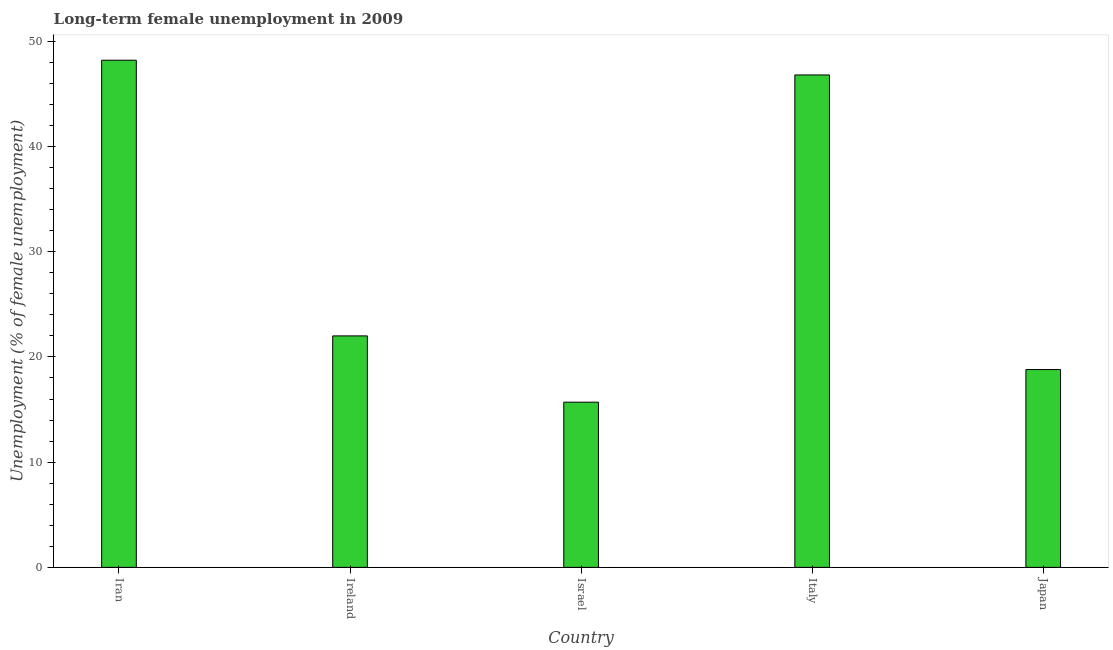Does the graph contain grids?
Offer a terse response. No. What is the title of the graph?
Provide a short and direct response. Long-term female unemployment in 2009. What is the label or title of the Y-axis?
Your answer should be compact. Unemployment (% of female unemployment). What is the long-term female unemployment in Ireland?
Give a very brief answer. 22. Across all countries, what is the maximum long-term female unemployment?
Your answer should be very brief. 48.2. Across all countries, what is the minimum long-term female unemployment?
Offer a terse response. 15.7. In which country was the long-term female unemployment maximum?
Give a very brief answer. Iran. In which country was the long-term female unemployment minimum?
Ensure brevity in your answer.  Israel. What is the sum of the long-term female unemployment?
Provide a succinct answer. 151.5. What is the difference between the long-term female unemployment in Ireland and Israel?
Make the answer very short. 6.3. What is the average long-term female unemployment per country?
Your response must be concise. 30.3. What is the median long-term female unemployment?
Give a very brief answer. 22. What is the ratio of the long-term female unemployment in Ireland to that in Japan?
Provide a short and direct response. 1.17. Is the long-term female unemployment in Iran less than that in Israel?
Keep it short and to the point. No. What is the difference between the highest and the second highest long-term female unemployment?
Give a very brief answer. 1.4. What is the difference between the highest and the lowest long-term female unemployment?
Keep it short and to the point. 32.5. What is the difference between two consecutive major ticks on the Y-axis?
Provide a short and direct response. 10. What is the Unemployment (% of female unemployment) of Iran?
Your response must be concise. 48.2. What is the Unemployment (% of female unemployment) of Ireland?
Offer a very short reply. 22. What is the Unemployment (% of female unemployment) of Israel?
Offer a terse response. 15.7. What is the Unemployment (% of female unemployment) of Italy?
Give a very brief answer. 46.8. What is the Unemployment (% of female unemployment) of Japan?
Ensure brevity in your answer.  18.8. What is the difference between the Unemployment (% of female unemployment) in Iran and Ireland?
Offer a terse response. 26.2. What is the difference between the Unemployment (% of female unemployment) in Iran and Israel?
Offer a very short reply. 32.5. What is the difference between the Unemployment (% of female unemployment) in Iran and Italy?
Provide a short and direct response. 1.4. What is the difference between the Unemployment (% of female unemployment) in Iran and Japan?
Make the answer very short. 29.4. What is the difference between the Unemployment (% of female unemployment) in Ireland and Italy?
Provide a succinct answer. -24.8. What is the difference between the Unemployment (% of female unemployment) in Ireland and Japan?
Your response must be concise. 3.2. What is the difference between the Unemployment (% of female unemployment) in Israel and Italy?
Keep it short and to the point. -31.1. What is the difference between the Unemployment (% of female unemployment) in Israel and Japan?
Your answer should be very brief. -3.1. What is the ratio of the Unemployment (% of female unemployment) in Iran to that in Ireland?
Keep it short and to the point. 2.19. What is the ratio of the Unemployment (% of female unemployment) in Iran to that in Israel?
Make the answer very short. 3.07. What is the ratio of the Unemployment (% of female unemployment) in Iran to that in Italy?
Your response must be concise. 1.03. What is the ratio of the Unemployment (% of female unemployment) in Iran to that in Japan?
Keep it short and to the point. 2.56. What is the ratio of the Unemployment (% of female unemployment) in Ireland to that in Israel?
Your response must be concise. 1.4. What is the ratio of the Unemployment (% of female unemployment) in Ireland to that in Italy?
Make the answer very short. 0.47. What is the ratio of the Unemployment (% of female unemployment) in Ireland to that in Japan?
Ensure brevity in your answer.  1.17. What is the ratio of the Unemployment (% of female unemployment) in Israel to that in Italy?
Your answer should be compact. 0.34. What is the ratio of the Unemployment (% of female unemployment) in Israel to that in Japan?
Provide a succinct answer. 0.83. What is the ratio of the Unemployment (% of female unemployment) in Italy to that in Japan?
Give a very brief answer. 2.49. 